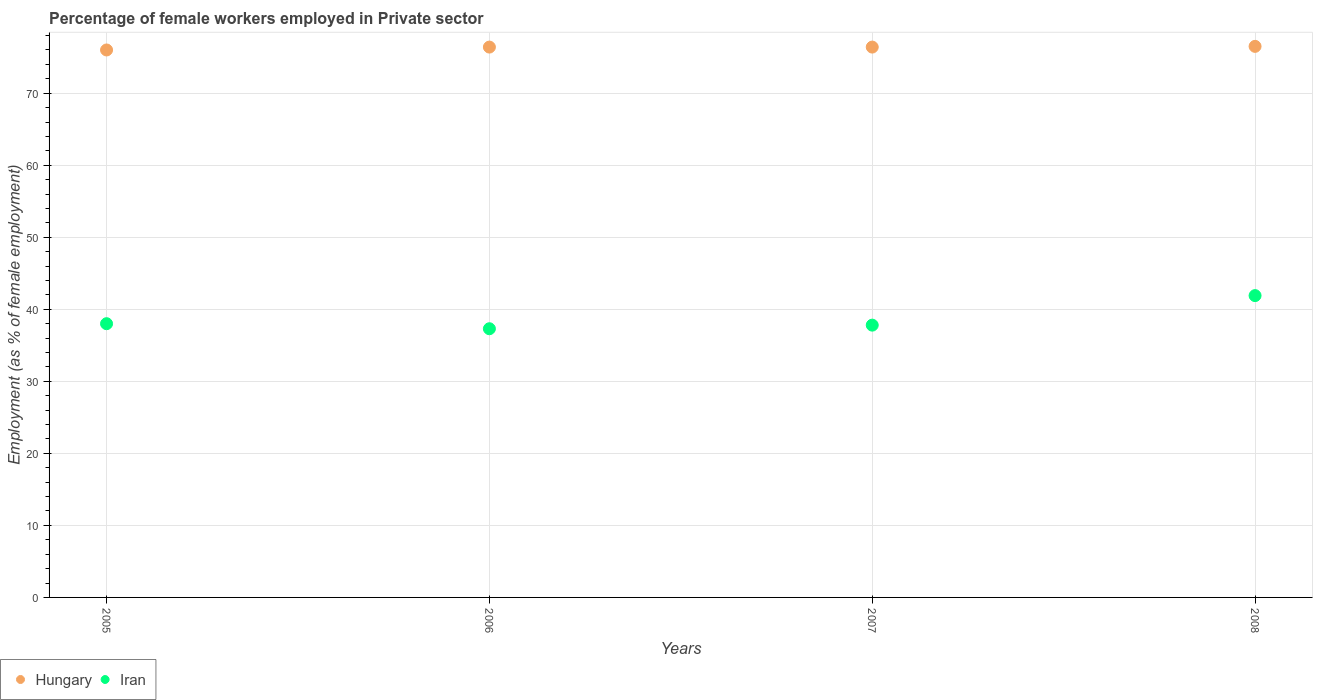Is the number of dotlines equal to the number of legend labels?
Keep it short and to the point. Yes. What is the percentage of females employed in Private sector in Hungary in 2006?
Ensure brevity in your answer.  76.4. Across all years, what is the maximum percentage of females employed in Private sector in Hungary?
Your response must be concise. 76.5. Across all years, what is the minimum percentage of females employed in Private sector in Hungary?
Give a very brief answer. 76. What is the total percentage of females employed in Private sector in Hungary in the graph?
Provide a succinct answer. 305.3. What is the difference between the percentage of females employed in Private sector in Iran in 2006 and that in 2007?
Your response must be concise. -0.5. What is the difference between the percentage of females employed in Private sector in Iran in 2005 and the percentage of females employed in Private sector in Hungary in 2008?
Your answer should be very brief. -38.5. What is the average percentage of females employed in Private sector in Iran per year?
Provide a succinct answer. 38.75. In the year 2006, what is the difference between the percentage of females employed in Private sector in Hungary and percentage of females employed in Private sector in Iran?
Provide a succinct answer. 39.1. What is the ratio of the percentage of females employed in Private sector in Iran in 2006 to that in 2008?
Your answer should be very brief. 0.89. Is the difference between the percentage of females employed in Private sector in Hungary in 2007 and 2008 greater than the difference between the percentage of females employed in Private sector in Iran in 2007 and 2008?
Your answer should be very brief. Yes. What is the difference between the highest and the second highest percentage of females employed in Private sector in Iran?
Provide a short and direct response. 3.9. What is the difference between the highest and the lowest percentage of females employed in Private sector in Iran?
Ensure brevity in your answer.  4.6. In how many years, is the percentage of females employed in Private sector in Hungary greater than the average percentage of females employed in Private sector in Hungary taken over all years?
Your answer should be very brief. 3. Is the percentage of females employed in Private sector in Hungary strictly greater than the percentage of females employed in Private sector in Iran over the years?
Your answer should be very brief. Yes. How many years are there in the graph?
Your response must be concise. 4. What is the difference between two consecutive major ticks on the Y-axis?
Make the answer very short. 10. Are the values on the major ticks of Y-axis written in scientific E-notation?
Provide a succinct answer. No. Does the graph contain any zero values?
Make the answer very short. No. Where does the legend appear in the graph?
Offer a very short reply. Bottom left. How are the legend labels stacked?
Give a very brief answer. Horizontal. What is the title of the graph?
Keep it short and to the point. Percentage of female workers employed in Private sector. Does "Oman" appear as one of the legend labels in the graph?
Provide a succinct answer. No. What is the label or title of the Y-axis?
Offer a terse response. Employment (as % of female employment). What is the Employment (as % of female employment) of Hungary in 2005?
Your answer should be very brief. 76. What is the Employment (as % of female employment) in Hungary in 2006?
Offer a very short reply. 76.4. What is the Employment (as % of female employment) in Iran in 2006?
Keep it short and to the point. 37.3. What is the Employment (as % of female employment) in Hungary in 2007?
Provide a short and direct response. 76.4. What is the Employment (as % of female employment) in Iran in 2007?
Your answer should be compact. 37.8. What is the Employment (as % of female employment) of Hungary in 2008?
Make the answer very short. 76.5. What is the Employment (as % of female employment) of Iran in 2008?
Ensure brevity in your answer.  41.9. Across all years, what is the maximum Employment (as % of female employment) in Hungary?
Offer a very short reply. 76.5. Across all years, what is the maximum Employment (as % of female employment) of Iran?
Your answer should be very brief. 41.9. Across all years, what is the minimum Employment (as % of female employment) in Iran?
Your answer should be compact. 37.3. What is the total Employment (as % of female employment) in Hungary in the graph?
Provide a short and direct response. 305.3. What is the total Employment (as % of female employment) of Iran in the graph?
Your response must be concise. 155. What is the difference between the Employment (as % of female employment) in Hungary in 2005 and that in 2006?
Make the answer very short. -0.4. What is the difference between the Employment (as % of female employment) in Hungary in 2005 and that in 2008?
Provide a succinct answer. -0.5. What is the difference between the Employment (as % of female employment) in Hungary in 2006 and that in 2007?
Provide a short and direct response. 0. What is the difference between the Employment (as % of female employment) in Iran in 2006 and that in 2007?
Provide a succinct answer. -0.5. What is the difference between the Employment (as % of female employment) in Iran in 2006 and that in 2008?
Offer a very short reply. -4.6. What is the difference between the Employment (as % of female employment) of Hungary in 2007 and that in 2008?
Your response must be concise. -0.1. What is the difference between the Employment (as % of female employment) of Hungary in 2005 and the Employment (as % of female employment) of Iran in 2006?
Provide a short and direct response. 38.7. What is the difference between the Employment (as % of female employment) of Hungary in 2005 and the Employment (as % of female employment) of Iran in 2007?
Your response must be concise. 38.2. What is the difference between the Employment (as % of female employment) of Hungary in 2005 and the Employment (as % of female employment) of Iran in 2008?
Your answer should be very brief. 34.1. What is the difference between the Employment (as % of female employment) of Hungary in 2006 and the Employment (as % of female employment) of Iran in 2007?
Provide a short and direct response. 38.6. What is the difference between the Employment (as % of female employment) in Hungary in 2006 and the Employment (as % of female employment) in Iran in 2008?
Give a very brief answer. 34.5. What is the difference between the Employment (as % of female employment) of Hungary in 2007 and the Employment (as % of female employment) of Iran in 2008?
Offer a terse response. 34.5. What is the average Employment (as % of female employment) of Hungary per year?
Your answer should be very brief. 76.33. What is the average Employment (as % of female employment) of Iran per year?
Ensure brevity in your answer.  38.75. In the year 2006, what is the difference between the Employment (as % of female employment) in Hungary and Employment (as % of female employment) in Iran?
Provide a succinct answer. 39.1. In the year 2007, what is the difference between the Employment (as % of female employment) in Hungary and Employment (as % of female employment) in Iran?
Offer a very short reply. 38.6. In the year 2008, what is the difference between the Employment (as % of female employment) in Hungary and Employment (as % of female employment) in Iran?
Offer a terse response. 34.6. What is the ratio of the Employment (as % of female employment) in Hungary in 2005 to that in 2006?
Keep it short and to the point. 0.99. What is the ratio of the Employment (as % of female employment) of Iran in 2005 to that in 2006?
Your response must be concise. 1.02. What is the ratio of the Employment (as % of female employment) in Iran in 2005 to that in 2007?
Provide a short and direct response. 1.01. What is the ratio of the Employment (as % of female employment) in Iran in 2005 to that in 2008?
Offer a very short reply. 0.91. What is the ratio of the Employment (as % of female employment) in Hungary in 2006 to that in 2007?
Ensure brevity in your answer.  1. What is the ratio of the Employment (as % of female employment) in Iran in 2006 to that in 2007?
Keep it short and to the point. 0.99. What is the ratio of the Employment (as % of female employment) of Iran in 2006 to that in 2008?
Offer a very short reply. 0.89. What is the ratio of the Employment (as % of female employment) of Iran in 2007 to that in 2008?
Offer a terse response. 0.9. What is the difference between the highest and the lowest Employment (as % of female employment) of Hungary?
Your answer should be compact. 0.5. What is the difference between the highest and the lowest Employment (as % of female employment) in Iran?
Keep it short and to the point. 4.6. 